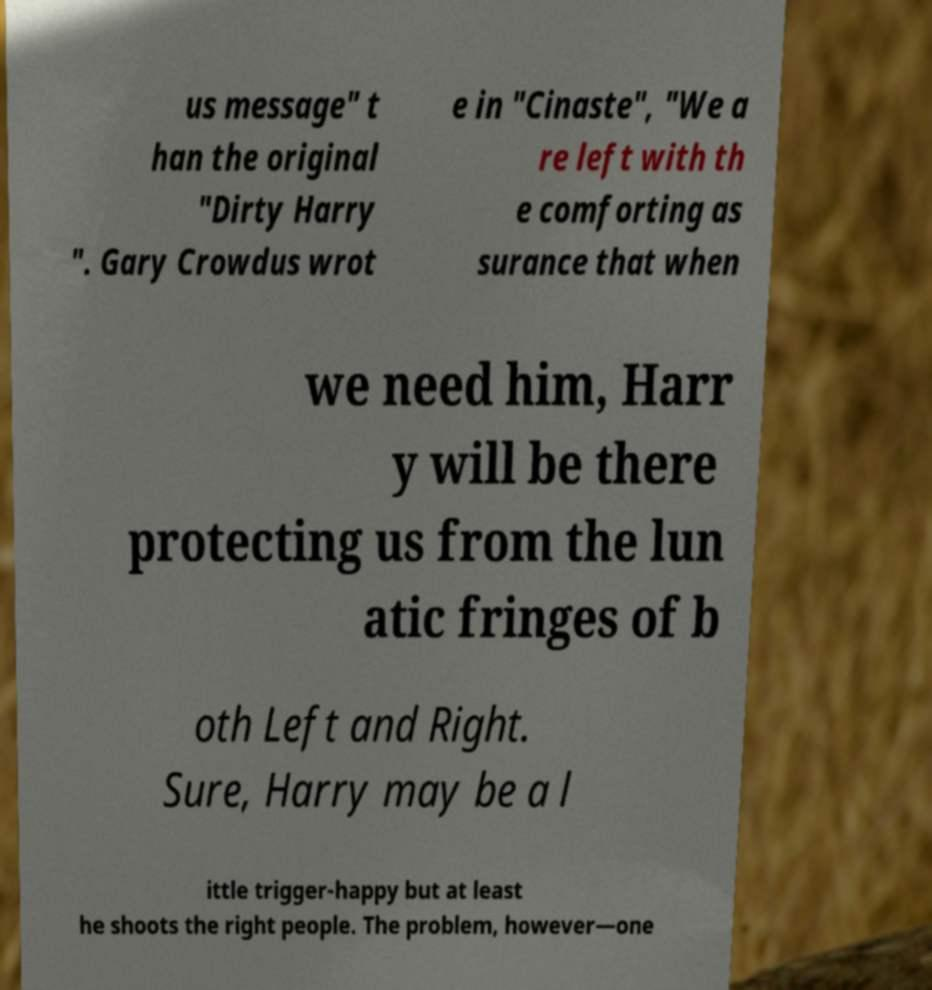Can you accurately transcribe the text from the provided image for me? us message" t han the original "Dirty Harry ". Gary Crowdus wrot e in "Cinaste", "We a re left with th e comforting as surance that when we need him, Harr y will be there protecting us from the lun atic fringes of b oth Left and Right. Sure, Harry may be a l ittle trigger-happy but at least he shoots the right people. The problem, however—one 